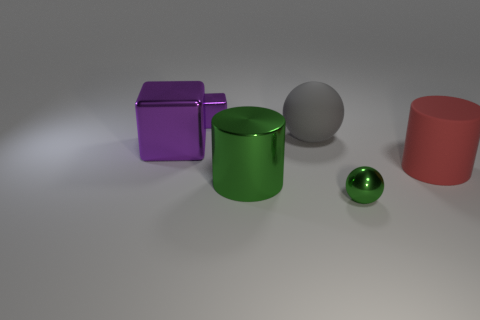Is there a large purple object to the left of the purple block left of the purple block behind the large gray rubber sphere?
Your answer should be very brief. No. There is a tiny thing that is in front of the green shiny cylinder; does it have the same shape as the gray rubber thing?
Your response must be concise. Yes. Are there fewer big red things to the right of the red thing than small purple things that are right of the small green metallic sphere?
Offer a terse response. No. What is the gray object made of?
Ensure brevity in your answer.  Rubber. There is a small shiny cube; is its color the same as the block that is on the left side of the tiny purple shiny object?
Offer a terse response. Yes. How many metallic blocks are in front of the small shiny sphere?
Your response must be concise. 0. Are there fewer purple shiny things that are in front of the large gray matte thing than large matte balls?
Your response must be concise. No. The tiny metal block is what color?
Provide a succinct answer. Purple. Is the color of the cylinder in front of the red rubber cylinder the same as the big metal block?
Keep it short and to the point. No. There is a big thing that is the same shape as the small green metallic object; what is its color?
Offer a very short reply. Gray. 